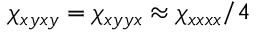<formula> <loc_0><loc_0><loc_500><loc_500>\chi _ { x y x y } = \chi _ { x y y x } \approx \chi _ { x x x x } / 4</formula> 